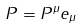<formula> <loc_0><loc_0><loc_500><loc_500>P = P ^ { \mu } e _ { \mu }</formula> 